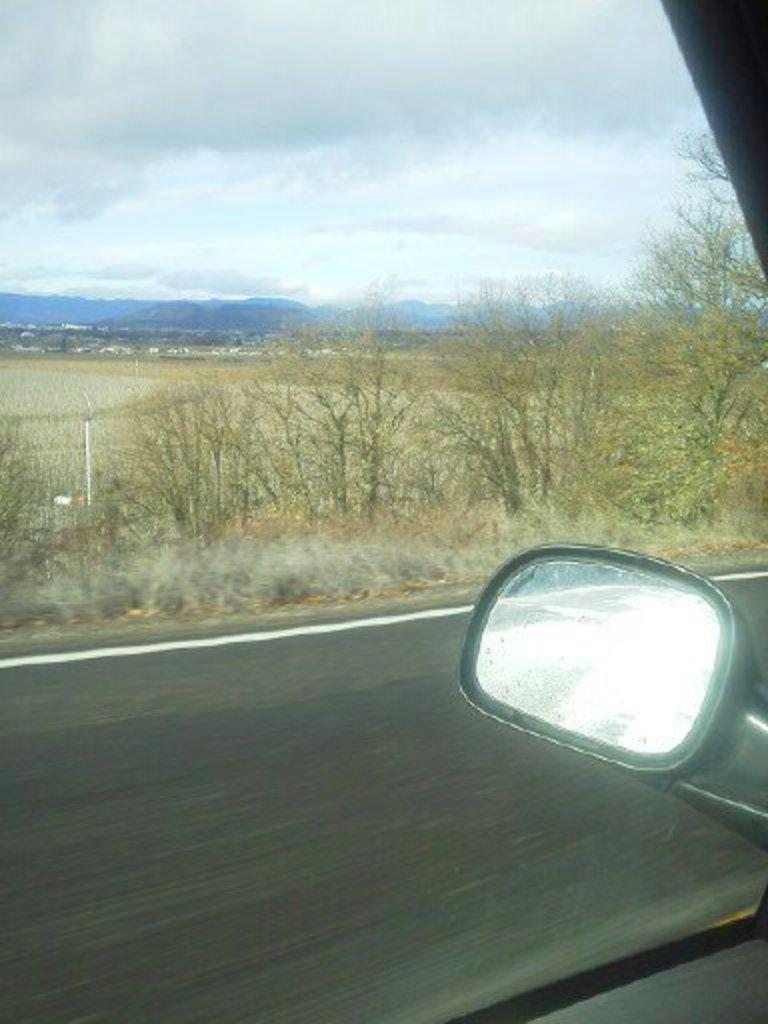What is the main subject of the image? The main subject of the image is a vehicle glass window. What can be seen through the window? A mirror, a road, trees, hills, and the sky are visible through the window. What is the condition of the sky in the image? The sky is visible through the window, and clouds are present in the sky. How many dinosaurs can be seen grazing on the hills through the window? There are no dinosaurs present in the image; the hills are visible through the window, but they do not contain any dinosaurs. What is the distribution of knee pads in the image? There are no knee pads present in the image, so it is not possible to discuss their distribution. 